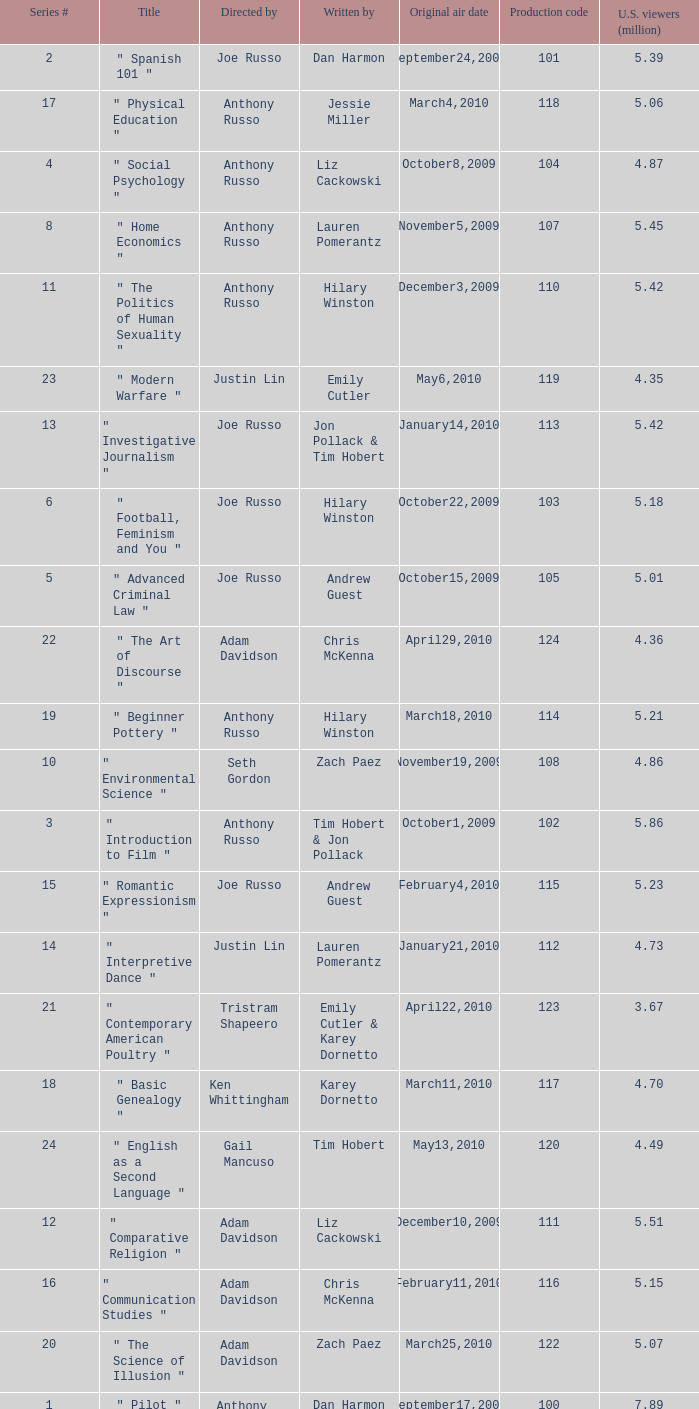What is the title of the series # 8? " Home Economics ". 